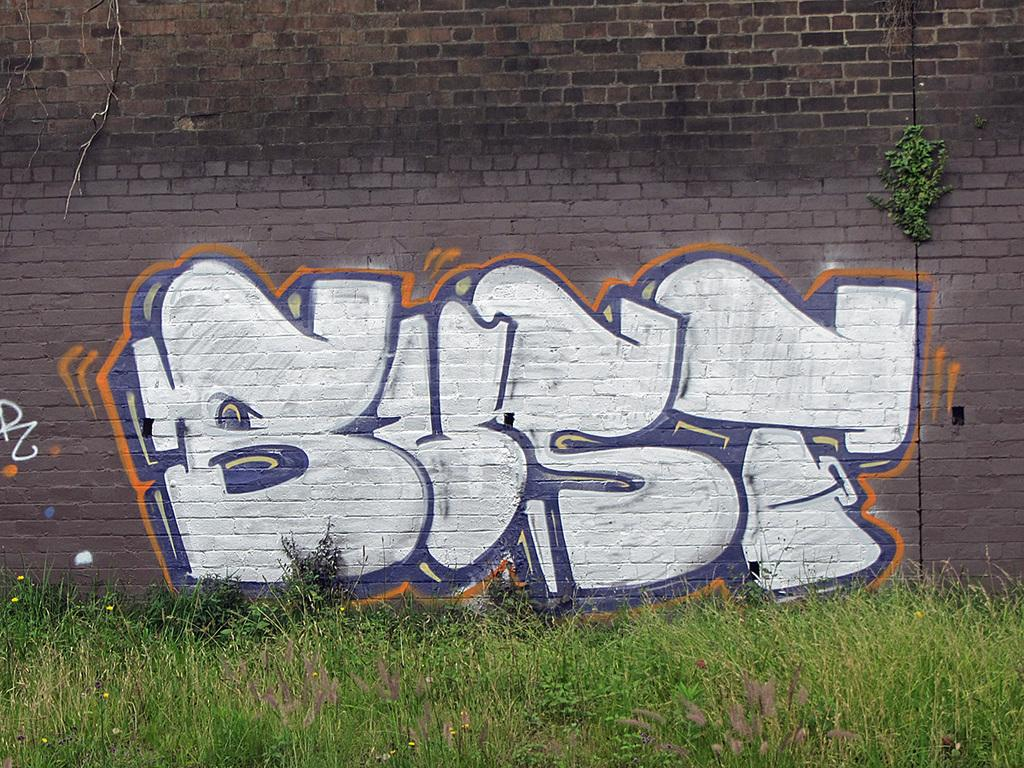What is hanging on the wall in the image? There is a painting on the wall in the image. What color is the grass in the image? The grass in the image is green in color. What type of ink is used in the painting in the image? There is no information about the type of ink used in the painting, as the facts provided do not mention it. How many sheep are present in the image? There are no sheep present in the image; the facts only mention a painting on the wall and green grass. 